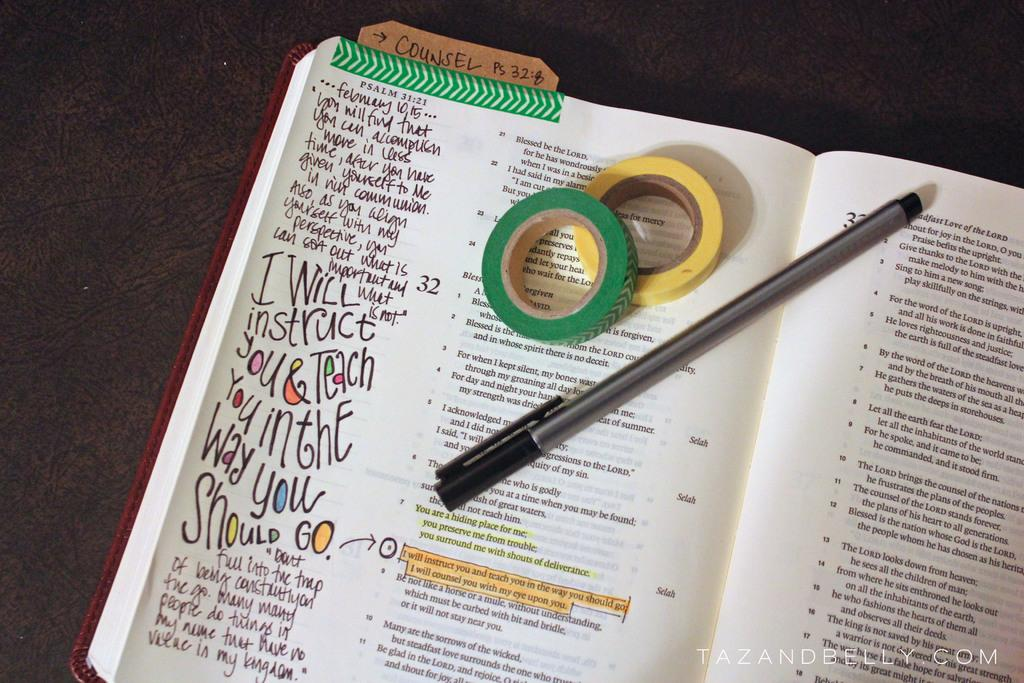What can be seen in the image related to reading or writing? There is a book in the image, and something is written in the book. What type of furniture is present in the image? There is a bench in the image. What else can be seen on a dark surface in the image? There are tapes on a dark surface in the image. Can you describe any additional details about the image? There is a watermark at the bottom right side of the image. Where is the cat sitting in the image? There is no cat present in the image. What type of locket is hanging from the bench in the image? There is no locket present in the image. 